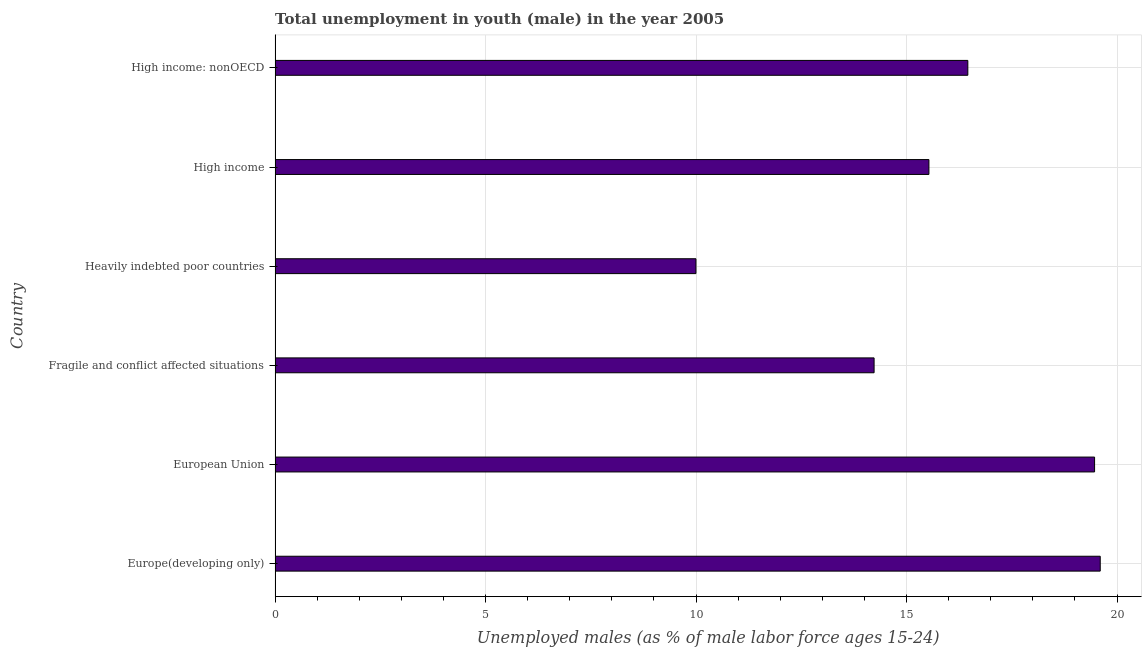Does the graph contain any zero values?
Your answer should be very brief. No. What is the title of the graph?
Provide a succinct answer. Total unemployment in youth (male) in the year 2005. What is the label or title of the X-axis?
Your answer should be compact. Unemployed males (as % of male labor force ages 15-24). What is the unemployed male youth population in Fragile and conflict affected situations?
Your answer should be very brief. 14.23. Across all countries, what is the maximum unemployed male youth population?
Your response must be concise. 19.6. Across all countries, what is the minimum unemployed male youth population?
Give a very brief answer. 10. In which country was the unemployed male youth population maximum?
Keep it short and to the point. Europe(developing only). In which country was the unemployed male youth population minimum?
Offer a terse response. Heavily indebted poor countries. What is the sum of the unemployed male youth population?
Make the answer very short. 95.28. What is the difference between the unemployed male youth population in Europe(developing only) and Fragile and conflict affected situations?
Keep it short and to the point. 5.37. What is the average unemployed male youth population per country?
Provide a short and direct response. 15.88. What is the median unemployed male youth population?
Make the answer very short. 15.99. What is the ratio of the unemployed male youth population in Heavily indebted poor countries to that in High income: nonOECD?
Ensure brevity in your answer.  0.61. Is the unemployed male youth population in Heavily indebted poor countries less than that in High income: nonOECD?
Make the answer very short. Yes. Is the difference between the unemployed male youth population in European Union and Heavily indebted poor countries greater than the difference between any two countries?
Ensure brevity in your answer.  No. What is the difference between the highest and the second highest unemployed male youth population?
Offer a very short reply. 0.13. Is the sum of the unemployed male youth population in Europe(developing only) and High income greater than the maximum unemployed male youth population across all countries?
Offer a very short reply. Yes. What is the difference between the highest and the lowest unemployed male youth population?
Give a very brief answer. 9.6. How many bars are there?
Offer a very short reply. 6. How many countries are there in the graph?
Your response must be concise. 6. What is the difference between two consecutive major ticks on the X-axis?
Offer a very short reply. 5. Are the values on the major ticks of X-axis written in scientific E-notation?
Make the answer very short. No. What is the Unemployed males (as % of male labor force ages 15-24) of Europe(developing only)?
Offer a very short reply. 19.6. What is the Unemployed males (as % of male labor force ages 15-24) in European Union?
Your response must be concise. 19.47. What is the Unemployed males (as % of male labor force ages 15-24) in Fragile and conflict affected situations?
Your answer should be compact. 14.23. What is the Unemployed males (as % of male labor force ages 15-24) of Heavily indebted poor countries?
Your response must be concise. 10. What is the Unemployed males (as % of male labor force ages 15-24) of High income?
Make the answer very short. 15.53. What is the Unemployed males (as % of male labor force ages 15-24) of High income: nonOECD?
Your response must be concise. 16.46. What is the difference between the Unemployed males (as % of male labor force ages 15-24) in Europe(developing only) and European Union?
Provide a succinct answer. 0.13. What is the difference between the Unemployed males (as % of male labor force ages 15-24) in Europe(developing only) and Fragile and conflict affected situations?
Keep it short and to the point. 5.37. What is the difference between the Unemployed males (as % of male labor force ages 15-24) in Europe(developing only) and Heavily indebted poor countries?
Give a very brief answer. 9.6. What is the difference between the Unemployed males (as % of male labor force ages 15-24) in Europe(developing only) and High income?
Your response must be concise. 4.07. What is the difference between the Unemployed males (as % of male labor force ages 15-24) in Europe(developing only) and High income: nonOECD?
Your answer should be compact. 3.14. What is the difference between the Unemployed males (as % of male labor force ages 15-24) in European Union and Fragile and conflict affected situations?
Your response must be concise. 5.24. What is the difference between the Unemployed males (as % of male labor force ages 15-24) in European Union and Heavily indebted poor countries?
Your response must be concise. 9.47. What is the difference between the Unemployed males (as % of male labor force ages 15-24) in European Union and High income?
Your response must be concise. 3.94. What is the difference between the Unemployed males (as % of male labor force ages 15-24) in European Union and High income: nonOECD?
Provide a succinct answer. 3.01. What is the difference between the Unemployed males (as % of male labor force ages 15-24) in Fragile and conflict affected situations and Heavily indebted poor countries?
Keep it short and to the point. 4.23. What is the difference between the Unemployed males (as % of male labor force ages 15-24) in Fragile and conflict affected situations and High income?
Your response must be concise. -1.3. What is the difference between the Unemployed males (as % of male labor force ages 15-24) in Fragile and conflict affected situations and High income: nonOECD?
Make the answer very short. -2.23. What is the difference between the Unemployed males (as % of male labor force ages 15-24) in Heavily indebted poor countries and High income?
Your answer should be compact. -5.53. What is the difference between the Unemployed males (as % of male labor force ages 15-24) in Heavily indebted poor countries and High income: nonOECD?
Provide a succinct answer. -6.46. What is the difference between the Unemployed males (as % of male labor force ages 15-24) in High income and High income: nonOECD?
Provide a succinct answer. -0.92. What is the ratio of the Unemployed males (as % of male labor force ages 15-24) in Europe(developing only) to that in Fragile and conflict affected situations?
Provide a short and direct response. 1.38. What is the ratio of the Unemployed males (as % of male labor force ages 15-24) in Europe(developing only) to that in Heavily indebted poor countries?
Your answer should be compact. 1.96. What is the ratio of the Unemployed males (as % of male labor force ages 15-24) in Europe(developing only) to that in High income?
Ensure brevity in your answer.  1.26. What is the ratio of the Unemployed males (as % of male labor force ages 15-24) in Europe(developing only) to that in High income: nonOECD?
Offer a terse response. 1.19. What is the ratio of the Unemployed males (as % of male labor force ages 15-24) in European Union to that in Fragile and conflict affected situations?
Make the answer very short. 1.37. What is the ratio of the Unemployed males (as % of male labor force ages 15-24) in European Union to that in Heavily indebted poor countries?
Your response must be concise. 1.95. What is the ratio of the Unemployed males (as % of male labor force ages 15-24) in European Union to that in High income?
Provide a short and direct response. 1.25. What is the ratio of the Unemployed males (as % of male labor force ages 15-24) in European Union to that in High income: nonOECD?
Offer a very short reply. 1.18. What is the ratio of the Unemployed males (as % of male labor force ages 15-24) in Fragile and conflict affected situations to that in Heavily indebted poor countries?
Offer a terse response. 1.42. What is the ratio of the Unemployed males (as % of male labor force ages 15-24) in Fragile and conflict affected situations to that in High income?
Offer a very short reply. 0.92. What is the ratio of the Unemployed males (as % of male labor force ages 15-24) in Fragile and conflict affected situations to that in High income: nonOECD?
Your answer should be very brief. 0.86. What is the ratio of the Unemployed males (as % of male labor force ages 15-24) in Heavily indebted poor countries to that in High income?
Offer a very short reply. 0.64. What is the ratio of the Unemployed males (as % of male labor force ages 15-24) in Heavily indebted poor countries to that in High income: nonOECD?
Give a very brief answer. 0.61. What is the ratio of the Unemployed males (as % of male labor force ages 15-24) in High income to that in High income: nonOECD?
Offer a very short reply. 0.94. 